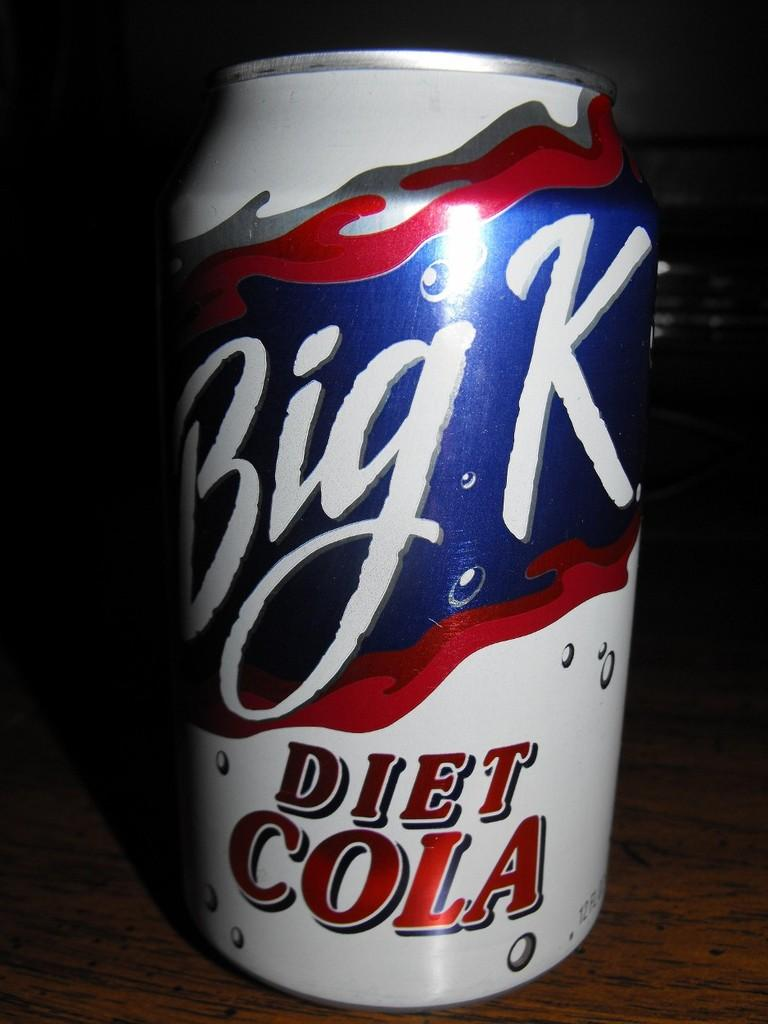<image>
Write a terse but informative summary of the picture. a Bik K soda that is on the ground 